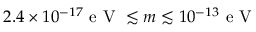Convert formula to latex. <formula><loc_0><loc_0><loc_500><loc_500>2 . 4 \times 1 0 ^ { - 1 7 } e V \lesssim m \lesssim 1 0 ^ { - 1 3 } e V</formula> 